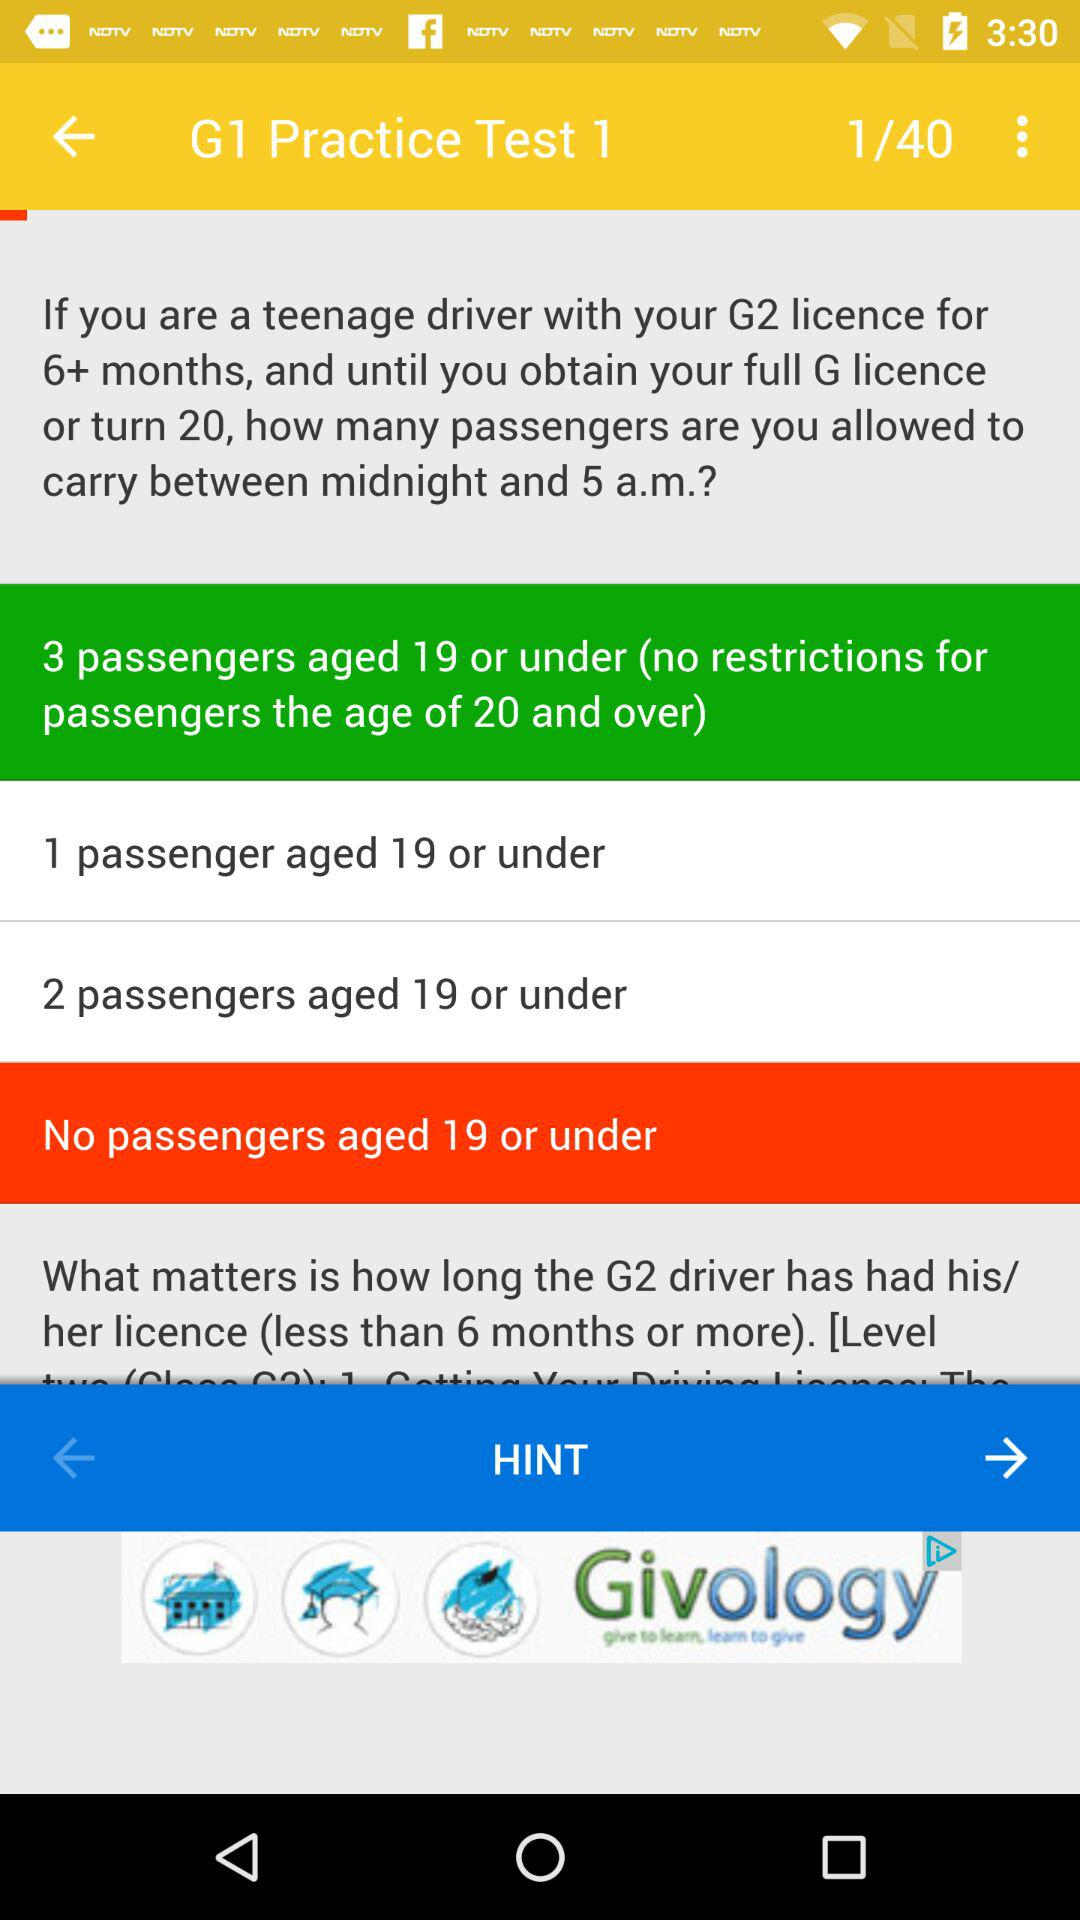What is the number of passengers who are aged 19 or under? The number of passengers who are aged 19 or under is 3. 